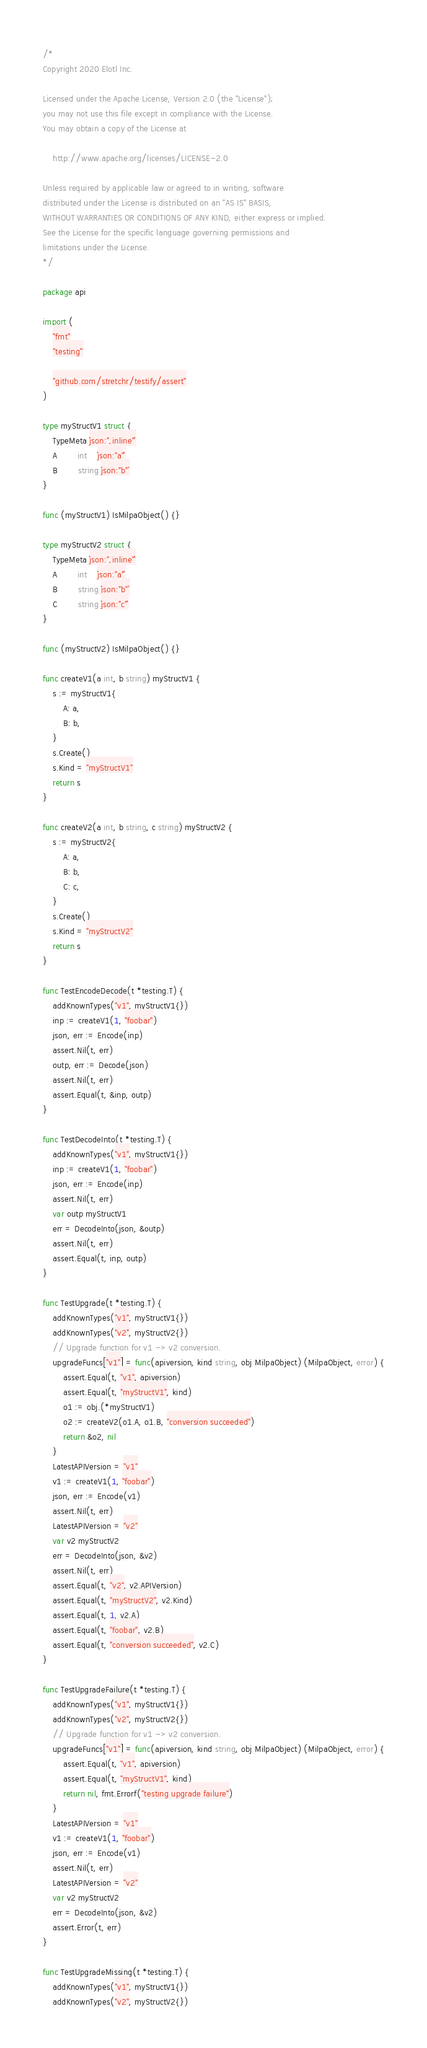Convert code to text. <code><loc_0><loc_0><loc_500><loc_500><_Go_>/*
Copyright 2020 Elotl Inc.

Licensed under the Apache License, Version 2.0 (the "License");
you may not use this file except in compliance with the License.
You may obtain a copy of the License at

    http://www.apache.org/licenses/LICENSE-2.0

Unless required by applicable law or agreed to in writing, software
distributed under the License is distributed on an "AS IS" BASIS,
WITHOUT WARRANTIES OR CONDITIONS OF ANY KIND, either express or implied.
See the License for the specific language governing permissions and
limitations under the License.
*/

package api

import (
	"fmt"
	"testing"

	"github.com/stretchr/testify/assert"
)

type myStructV1 struct {
	TypeMeta `json:",inline"`
	A        int    `json:"a"`
	B        string `json:"b"`
}

func (myStructV1) IsMilpaObject() {}

type myStructV2 struct {
	TypeMeta `json:",inline"`
	A        int    `json:"a"`
	B        string `json:"b"`
	C        string `json:"c"`
}

func (myStructV2) IsMilpaObject() {}

func createV1(a int, b string) myStructV1 {
	s := myStructV1{
		A: a,
		B: b,
	}
	s.Create()
	s.Kind = "myStructV1"
	return s
}

func createV2(a int, b string, c string) myStructV2 {
	s := myStructV2{
		A: a,
		B: b,
		C: c,
	}
	s.Create()
	s.Kind = "myStructV2"
	return s
}

func TestEncodeDecode(t *testing.T) {
	addKnownTypes("v1", myStructV1{})
	inp := createV1(1, "foobar")
	json, err := Encode(inp)
	assert.Nil(t, err)
	outp, err := Decode(json)
	assert.Nil(t, err)
	assert.Equal(t, &inp, outp)
}

func TestDecodeInto(t *testing.T) {
	addKnownTypes("v1", myStructV1{})
	inp := createV1(1, "foobar")
	json, err := Encode(inp)
	assert.Nil(t, err)
	var outp myStructV1
	err = DecodeInto(json, &outp)
	assert.Nil(t, err)
	assert.Equal(t, inp, outp)
}

func TestUpgrade(t *testing.T) {
	addKnownTypes("v1", myStructV1{})
	addKnownTypes("v2", myStructV2{})
	// Upgrade function for v1 -> v2 conversion.
	upgradeFuncs["v1"] = func(apiversion, kind string, obj MilpaObject) (MilpaObject, error) {
		assert.Equal(t, "v1", apiversion)
		assert.Equal(t, "myStructV1", kind)
		o1 := obj.(*myStructV1)
		o2 := createV2(o1.A, o1.B, "conversion succeeded")
		return &o2, nil
	}
	LatestAPIVersion = "v1"
	v1 := createV1(1, "foobar")
	json, err := Encode(v1)
	assert.Nil(t, err)
	LatestAPIVersion = "v2"
	var v2 myStructV2
	err = DecodeInto(json, &v2)
	assert.Nil(t, err)
	assert.Equal(t, "v2", v2.APIVersion)
	assert.Equal(t, "myStructV2", v2.Kind)
	assert.Equal(t, 1, v2.A)
	assert.Equal(t, "foobar", v2.B)
	assert.Equal(t, "conversion succeeded", v2.C)
}

func TestUpgradeFailure(t *testing.T) {
	addKnownTypes("v1", myStructV1{})
	addKnownTypes("v2", myStructV2{})
	// Upgrade function for v1 -> v2 conversion.
	upgradeFuncs["v1"] = func(apiversion, kind string, obj MilpaObject) (MilpaObject, error) {
		assert.Equal(t, "v1", apiversion)
		assert.Equal(t, "myStructV1", kind)
		return nil, fmt.Errorf("testing upgrade failure")
	}
	LatestAPIVersion = "v1"
	v1 := createV1(1, "foobar")
	json, err := Encode(v1)
	assert.Nil(t, err)
	LatestAPIVersion = "v2"
	var v2 myStructV2
	err = DecodeInto(json, &v2)
	assert.Error(t, err)
}

func TestUpgradeMissing(t *testing.T) {
	addKnownTypes("v1", myStructV1{})
	addKnownTypes("v2", myStructV2{})</code> 